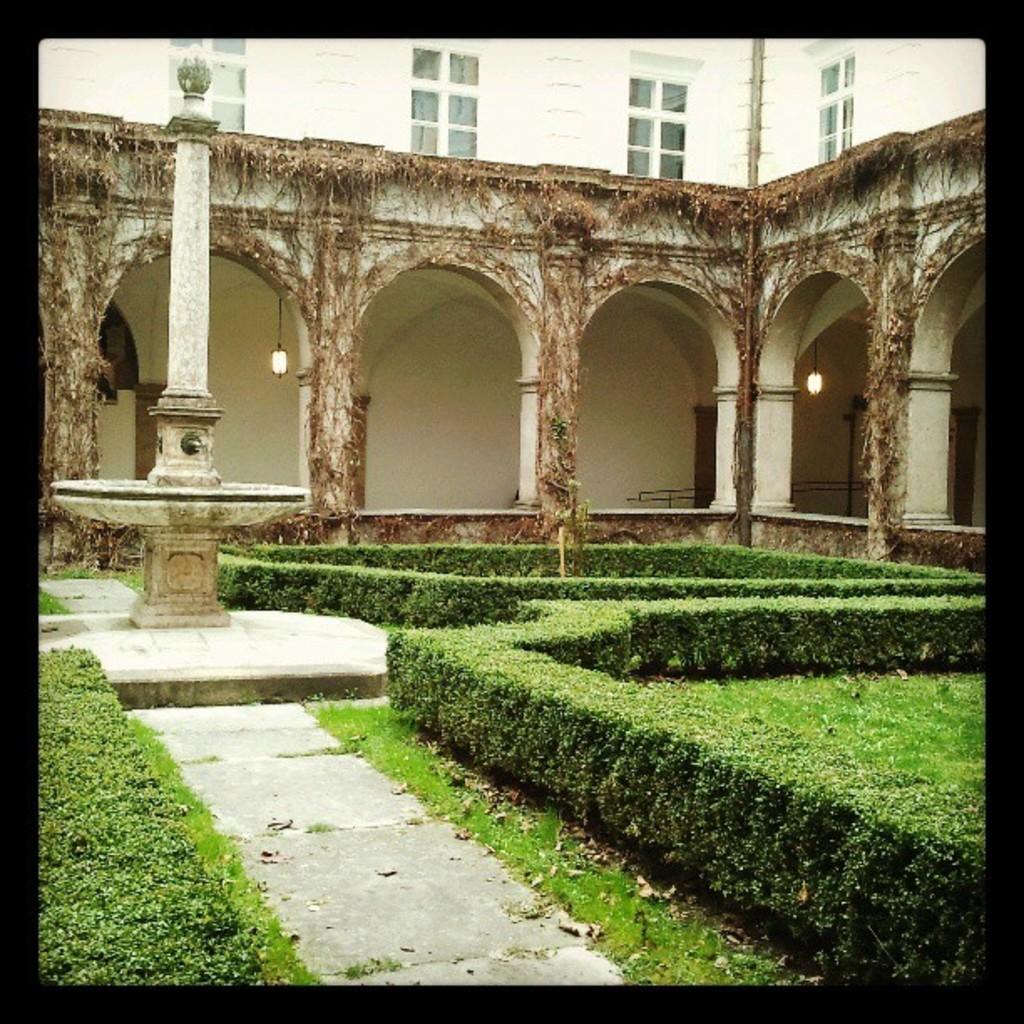How would you summarize this image in a sentence or two? In this image in the front there's grass on the ground and there are plants. In the center there is a pillar and in the background there is a building and there are arches and there are lights hanging. 